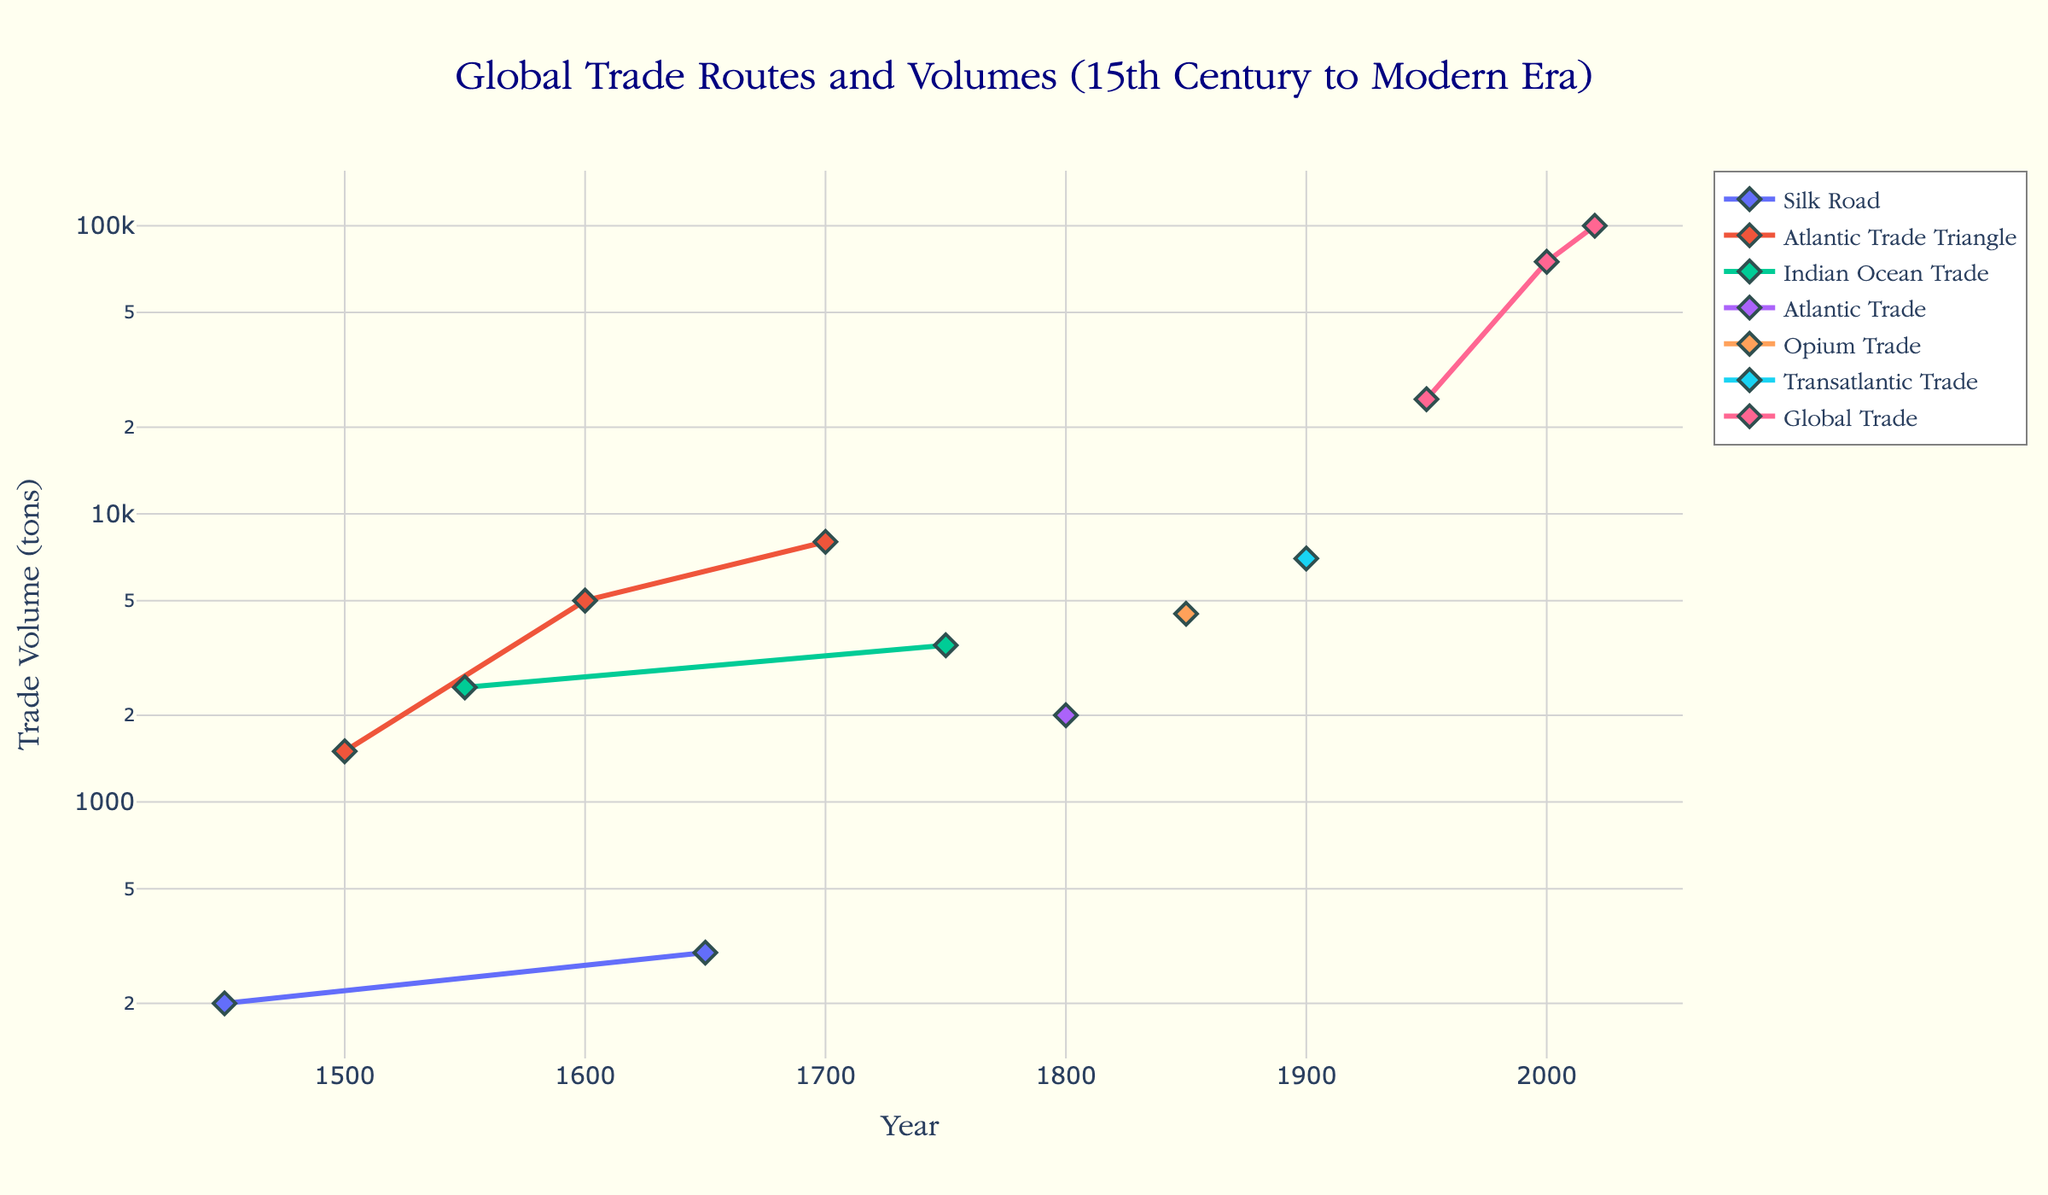What's the title of the figure? The title of the figure is text at the top and center of the plot, which gives an overview of the visualized data.
Answer: Global Trade Routes and Volumes (15th Century to Modern Era) Which trade route shows the highest trade volume in the year 2020? To find this, look at the data points for the year 2020. The marker with the highest y-value corresponds to 'Global Trade'.
Answer: Global Trade How many unique trade routes are represented in the plot? Count the unique entries in the legend under 'Trade_Route'. Each distinct trade route name in the legend represents a unique route.
Answer: 6 In which year did the trade volume for the Indian Ocean Trade peak? Find the points labeled 'Indian Ocean Trade' and compare their y-values. The peak is where the y-value (trade volume) is highest.
Answer: 1750 What significant event is annotated around the year 1869? Check the annotations on the plot for the specific year. The annotation text near 1869 mentions the event.
Answer: Suez Canal opens How does the trade volume in 1950 compare to that in 2000 for Global Trade? Look at the 'Global Trade' markers in the years 1950 and 2000. Compare the y-values and calculate the difference or ratio if necessary.
Answer: 2000 is 3 times larger Which trade route had a significant trade volume of 5000 tons around 1600? Check the plot for the data point around 1600 and check the trade route label associated with the y-value of 5000 tons.
Answer: Atlantic Trade Triangle What trend do you observe in the trade volume of the Atlantic Trade Triangle from 1500 to 1700? Trace the 'Atlantic Trade Triangle' along the timeline from 1500 to 1700 and observe the change in y-values, indicating if the trade volume increased, decreased, or remained stable.
Answer: Increased How does the trade volume of the Silk Road in 1650 compare to its volume in 1450? Locate the ‘Silk Road’ markers at 1450 and 1650 and compare their y-values.
Answer: Slight increase Which commodities are associated with the highest trade volume in the year 1950? Identify the data point for the year 1950. The `hovertemplate` displays the main commodities associated with that year's data.
Answer: Oil/Coffee 